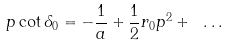Convert formula to latex. <formula><loc_0><loc_0><loc_500><loc_500>p \cot \delta _ { 0 } = - { \frac { 1 } { a } } + { \frac { 1 } { 2 } } r _ { 0 } p ^ { 2 } + \ \dots</formula> 